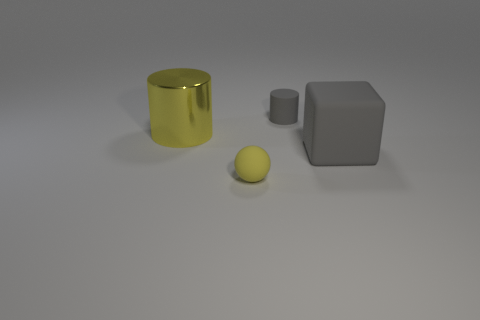Add 4 small cyan metal objects. How many objects exist? 8 Subtract all cubes. How many objects are left? 3 Subtract 1 balls. How many balls are left? 0 Subtract all yellow blocks. Subtract all cyan balls. How many blocks are left? 1 Subtract all red spheres. How many gray cylinders are left? 1 Subtract all big yellow rubber things. Subtract all matte things. How many objects are left? 1 Add 1 large gray rubber objects. How many large gray rubber objects are left? 2 Add 2 large matte objects. How many large matte objects exist? 3 Subtract all yellow cylinders. How many cylinders are left? 1 Subtract 1 yellow spheres. How many objects are left? 3 